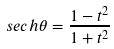Convert formula to latex. <formula><loc_0><loc_0><loc_500><loc_500>s e c h \theta = \frac { 1 - t ^ { 2 } } { 1 + t ^ { 2 } }</formula> 